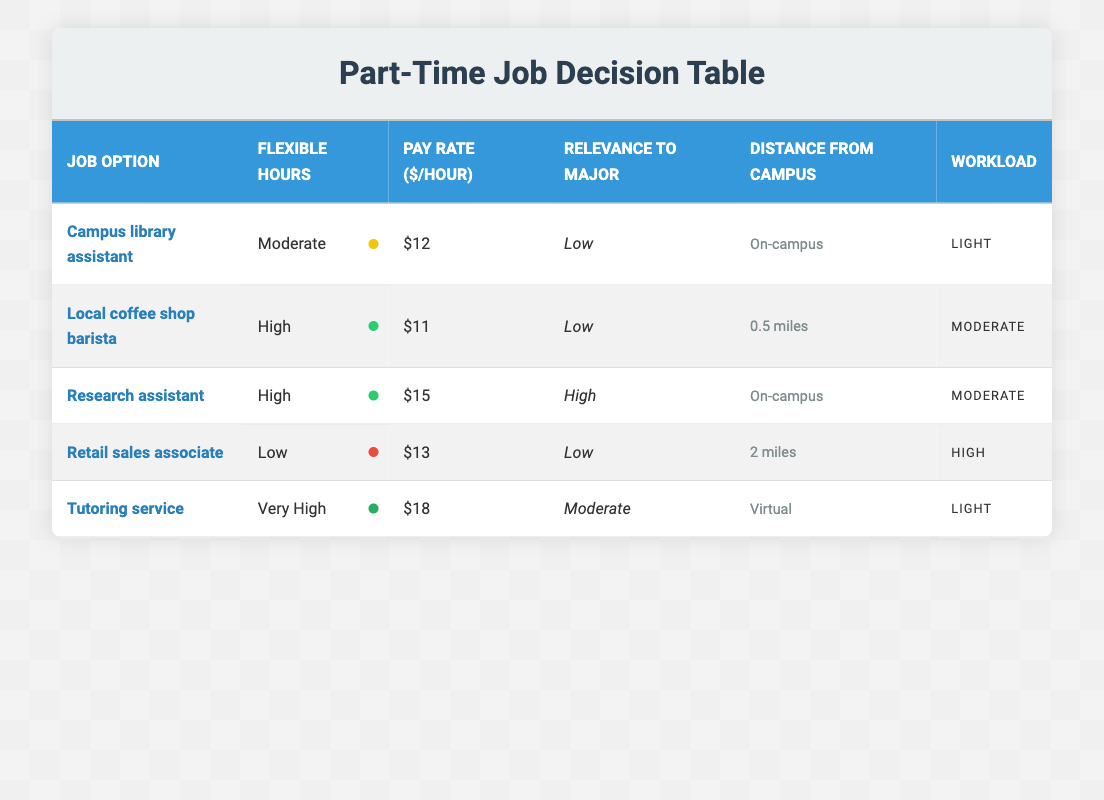What is the pay rate for the research assistant? According to the table, the pay rate for the research assistant is listed as $15 per hour.
Answer: $15 Which job option has the highest flexible hours? The tutoring service has the highest flexible hours, categorized as "Very High" in the table.
Answer: Tutoring service Is the pay rate for the local coffee shop barista higher than the campus library assistant? The local coffee shop barista has a pay rate of $11, and the campus library assistant has a pay rate of $12. Since $11 is less than $12, the statement is false.
Answer: No What is the average pay rate of all job options? To find the average, add up the pay rates: 12 + 11 + 15 + 13 + 18 = 69. There are 5 job options, so the average pay rate is 69 divided by 5, which equals 13.8.
Answer: 13.8 Which job option is both on-campus and has moderate workload? The research assistant is identified in the table as being on-campus and has a moderate workload.
Answer: Research assistant What percentage of job options have a low relevance to major? There are 5 job options in total: 3 of them (Campus library assistant, Local coffee shop barista, Retail sales associate) are marked with low relevance to major, which equates to 3 out of 5. To get the percentage, divide 3 by 5 to get 0.6 and then multiply by 100, which results in 60%.
Answer: 60% Is there a job option that offers light workload with very high flexible hours? The tutoring service indicates that it has a light workload and is classified as having very high flexible hours. Thus, the statement is true.
Answer: Yes What is the distance from campus for the retail sales associate? The table indicates that the distance from campus for the retail sales associate is 2 miles.
Answer: 2 miles 